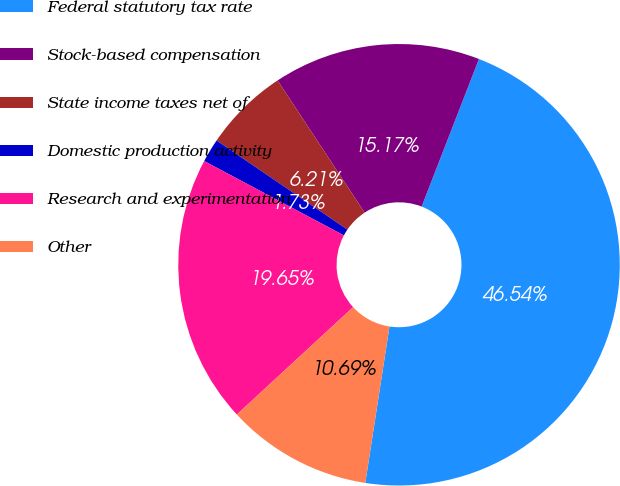<chart> <loc_0><loc_0><loc_500><loc_500><pie_chart><fcel>Federal statutory tax rate<fcel>Stock-based compensation<fcel>State income taxes net of<fcel>Domestic production activity<fcel>Research and experimentation<fcel>Other<nl><fcel>46.54%<fcel>15.17%<fcel>6.21%<fcel>1.73%<fcel>19.65%<fcel>10.69%<nl></chart> 